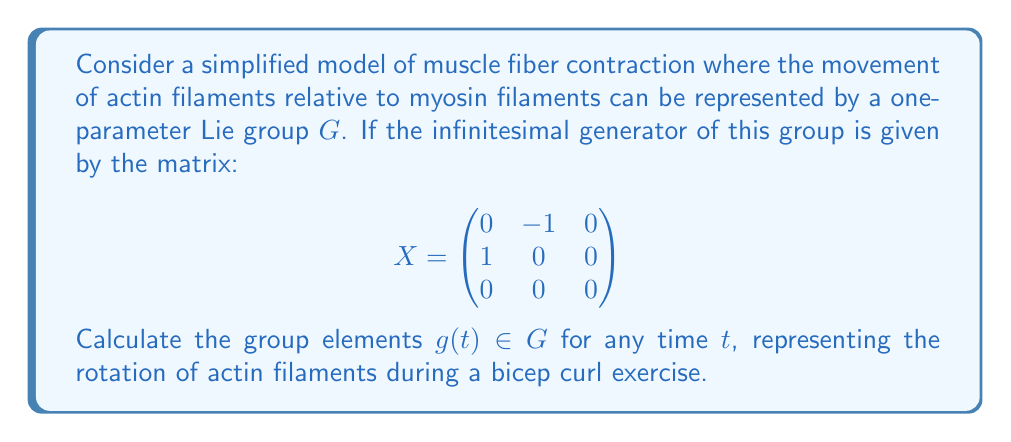Help me with this question. To solve this problem, we'll follow these steps:

1) The given matrix $X$ is the infinitesimal generator of the Lie group. This means that the group elements can be obtained through the matrix exponential:

   $g(t) = e^{tX}$

2) To calculate $e^{tX}$, we can use the matrix exponential formula:

   $e^{tX} = I + tX + \frac{t^2X^2}{2!} + \frac{t^3X^3}{3!} + ...$

3) Let's calculate the powers of $X$:

   $X^2 = \begin{pmatrix}
   -1 & 0 & 0 \\
   0 & -1 & 0 \\
   0 & 0 & 0
   \end{pmatrix}$

   $X^3 = \begin{pmatrix}
   0 & 1 & 0 \\
   -1 & 0 & 0 \\
   0 & 0 & 0
   \end{pmatrix} = -X$

   $X^4 = X^2$

4) We can see a pattern forming. The odd powers of $X$ alternate between $X$ and $-X$, while the even powers alternate between $-I$ and $X^2$.

5) Substituting these into the exponential series:

   $e^{tX} = I + tX + \frac{t^2}{2!}(-I) + \frac{t^3}{3!}(-X) + \frac{t^4}{4!}(-I) + ...$

6) This series can be recognized as the sum of cosine and sine series:

   $e^{tX} = (\cos t)I + (\sin t)X + (1-\cos t)X^2$

7) Substituting the values for $I$, $X$, and $X^2$:

   $e^{tX} = \begin{pmatrix}
   \cos t & -\sin t & 0 \\
   \sin t & \cos t & 0 \\
   0 & 0 & 1
   \end{pmatrix}$

This matrix represents a rotation in the xy-plane by an angle $t$, which models the circular motion of actin filaments relative to myosin filaments during a bicep curl.
Answer: $g(t) = \begin{pmatrix}
\cos t & -\sin t & 0 \\
\sin t & \cos t & 0 \\
0 & 0 & 1
\end{pmatrix}$ 